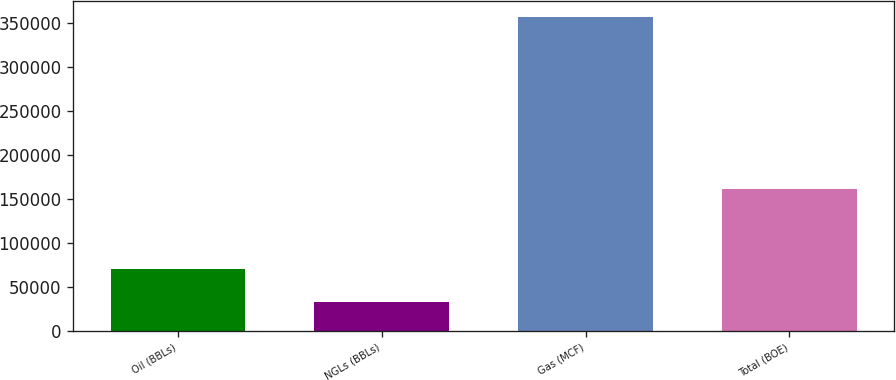<chart> <loc_0><loc_0><loc_500><loc_500><bar_chart><fcel>Oil (BBLs)<fcel>NGLs (BBLs)<fcel>Gas (MCF)<fcel>Total (BOE)<nl><fcel>69527<fcel>32422<fcel>357044<fcel>161456<nl></chart> 